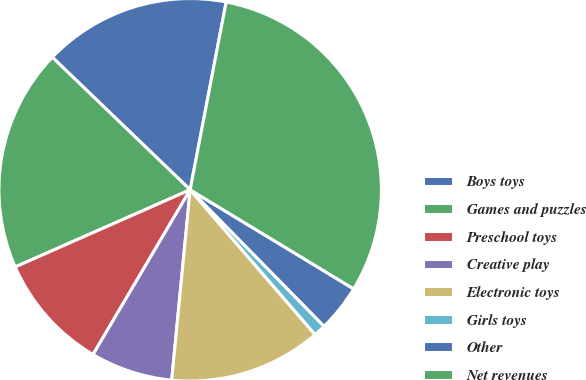Convert chart to OTSL. <chart><loc_0><loc_0><loc_500><loc_500><pie_chart><fcel>Boys toys<fcel>Games and puzzles<fcel>Preschool toys<fcel>Creative play<fcel>Electronic toys<fcel>Girls toys<fcel>Other<fcel>Net revenues<nl><fcel>15.83%<fcel>18.8%<fcel>9.91%<fcel>6.94%<fcel>12.87%<fcel>1.02%<fcel>3.98%<fcel>30.65%<nl></chart> 